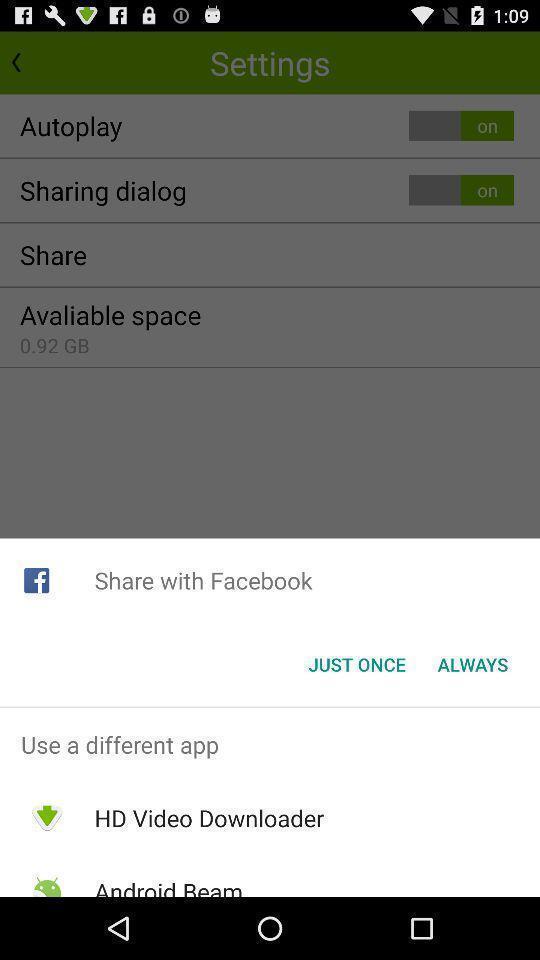Summarize the main components in this picture. Screen display share options. 